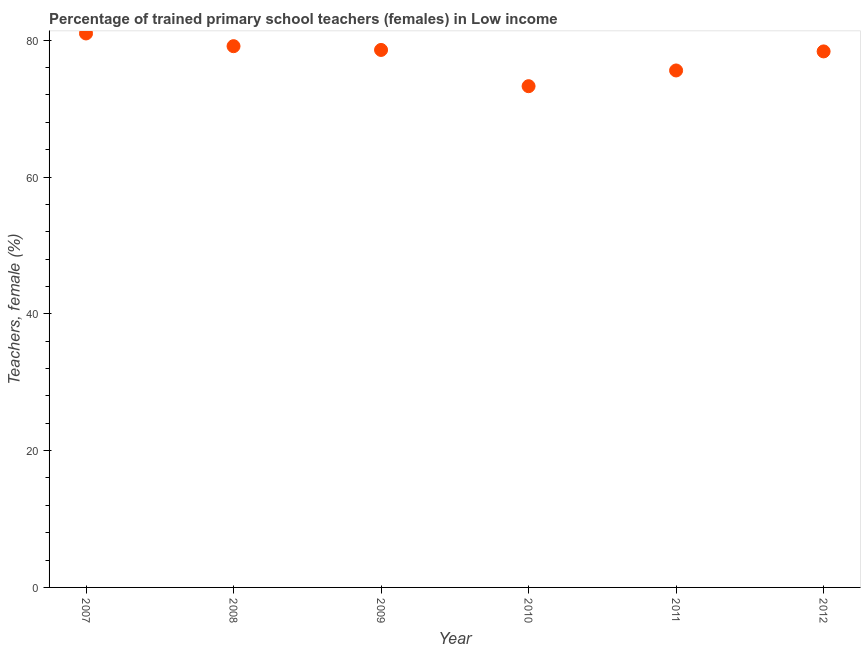What is the percentage of trained female teachers in 2011?
Offer a very short reply. 75.58. Across all years, what is the maximum percentage of trained female teachers?
Ensure brevity in your answer.  80.99. Across all years, what is the minimum percentage of trained female teachers?
Make the answer very short. 73.29. What is the sum of the percentage of trained female teachers?
Your answer should be compact. 465.95. What is the difference between the percentage of trained female teachers in 2010 and 2012?
Offer a terse response. -5.08. What is the average percentage of trained female teachers per year?
Your response must be concise. 77.66. What is the median percentage of trained female teachers?
Your answer should be very brief. 78.48. Do a majority of the years between 2007 and 2008 (inclusive) have percentage of trained female teachers greater than 40 %?
Make the answer very short. Yes. What is the ratio of the percentage of trained female teachers in 2010 to that in 2011?
Offer a very short reply. 0.97. Is the difference between the percentage of trained female teachers in 2008 and 2010 greater than the difference between any two years?
Offer a terse response. No. What is the difference between the highest and the second highest percentage of trained female teachers?
Ensure brevity in your answer.  1.86. What is the difference between the highest and the lowest percentage of trained female teachers?
Your answer should be very brief. 7.71. How many dotlines are there?
Offer a very short reply. 1. What is the difference between two consecutive major ticks on the Y-axis?
Offer a very short reply. 20. Does the graph contain any zero values?
Provide a succinct answer. No. What is the title of the graph?
Give a very brief answer. Percentage of trained primary school teachers (females) in Low income. What is the label or title of the Y-axis?
Offer a terse response. Teachers, female (%). What is the Teachers, female (%) in 2007?
Ensure brevity in your answer.  80.99. What is the Teachers, female (%) in 2008?
Make the answer very short. 79.13. What is the Teachers, female (%) in 2009?
Your response must be concise. 78.58. What is the Teachers, female (%) in 2010?
Give a very brief answer. 73.29. What is the Teachers, female (%) in 2011?
Offer a terse response. 75.58. What is the Teachers, female (%) in 2012?
Provide a succinct answer. 78.37. What is the difference between the Teachers, female (%) in 2007 and 2008?
Your answer should be very brief. 1.86. What is the difference between the Teachers, female (%) in 2007 and 2009?
Offer a terse response. 2.41. What is the difference between the Teachers, female (%) in 2007 and 2010?
Provide a succinct answer. 7.71. What is the difference between the Teachers, female (%) in 2007 and 2011?
Offer a very short reply. 5.41. What is the difference between the Teachers, female (%) in 2007 and 2012?
Offer a very short reply. 2.62. What is the difference between the Teachers, female (%) in 2008 and 2009?
Your answer should be very brief. 0.55. What is the difference between the Teachers, female (%) in 2008 and 2010?
Your response must be concise. 5.85. What is the difference between the Teachers, female (%) in 2008 and 2011?
Offer a very short reply. 3.55. What is the difference between the Teachers, female (%) in 2008 and 2012?
Keep it short and to the point. 0.77. What is the difference between the Teachers, female (%) in 2009 and 2010?
Provide a succinct answer. 5.3. What is the difference between the Teachers, female (%) in 2009 and 2011?
Provide a succinct answer. 3. What is the difference between the Teachers, female (%) in 2009 and 2012?
Give a very brief answer. 0.22. What is the difference between the Teachers, female (%) in 2010 and 2011?
Make the answer very short. -2.3. What is the difference between the Teachers, female (%) in 2010 and 2012?
Offer a terse response. -5.08. What is the difference between the Teachers, female (%) in 2011 and 2012?
Offer a very short reply. -2.79. What is the ratio of the Teachers, female (%) in 2007 to that in 2008?
Ensure brevity in your answer.  1.02. What is the ratio of the Teachers, female (%) in 2007 to that in 2009?
Keep it short and to the point. 1.03. What is the ratio of the Teachers, female (%) in 2007 to that in 2010?
Your answer should be compact. 1.1. What is the ratio of the Teachers, female (%) in 2007 to that in 2011?
Your answer should be very brief. 1.07. What is the ratio of the Teachers, female (%) in 2007 to that in 2012?
Offer a very short reply. 1.03. What is the ratio of the Teachers, female (%) in 2008 to that in 2009?
Your answer should be compact. 1.01. What is the ratio of the Teachers, female (%) in 2008 to that in 2011?
Provide a succinct answer. 1.05. What is the ratio of the Teachers, female (%) in 2008 to that in 2012?
Your answer should be very brief. 1.01. What is the ratio of the Teachers, female (%) in 2009 to that in 2010?
Keep it short and to the point. 1.07. What is the ratio of the Teachers, female (%) in 2010 to that in 2011?
Your answer should be very brief. 0.97. What is the ratio of the Teachers, female (%) in 2010 to that in 2012?
Give a very brief answer. 0.94. What is the ratio of the Teachers, female (%) in 2011 to that in 2012?
Give a very brief answer. 0.96. 